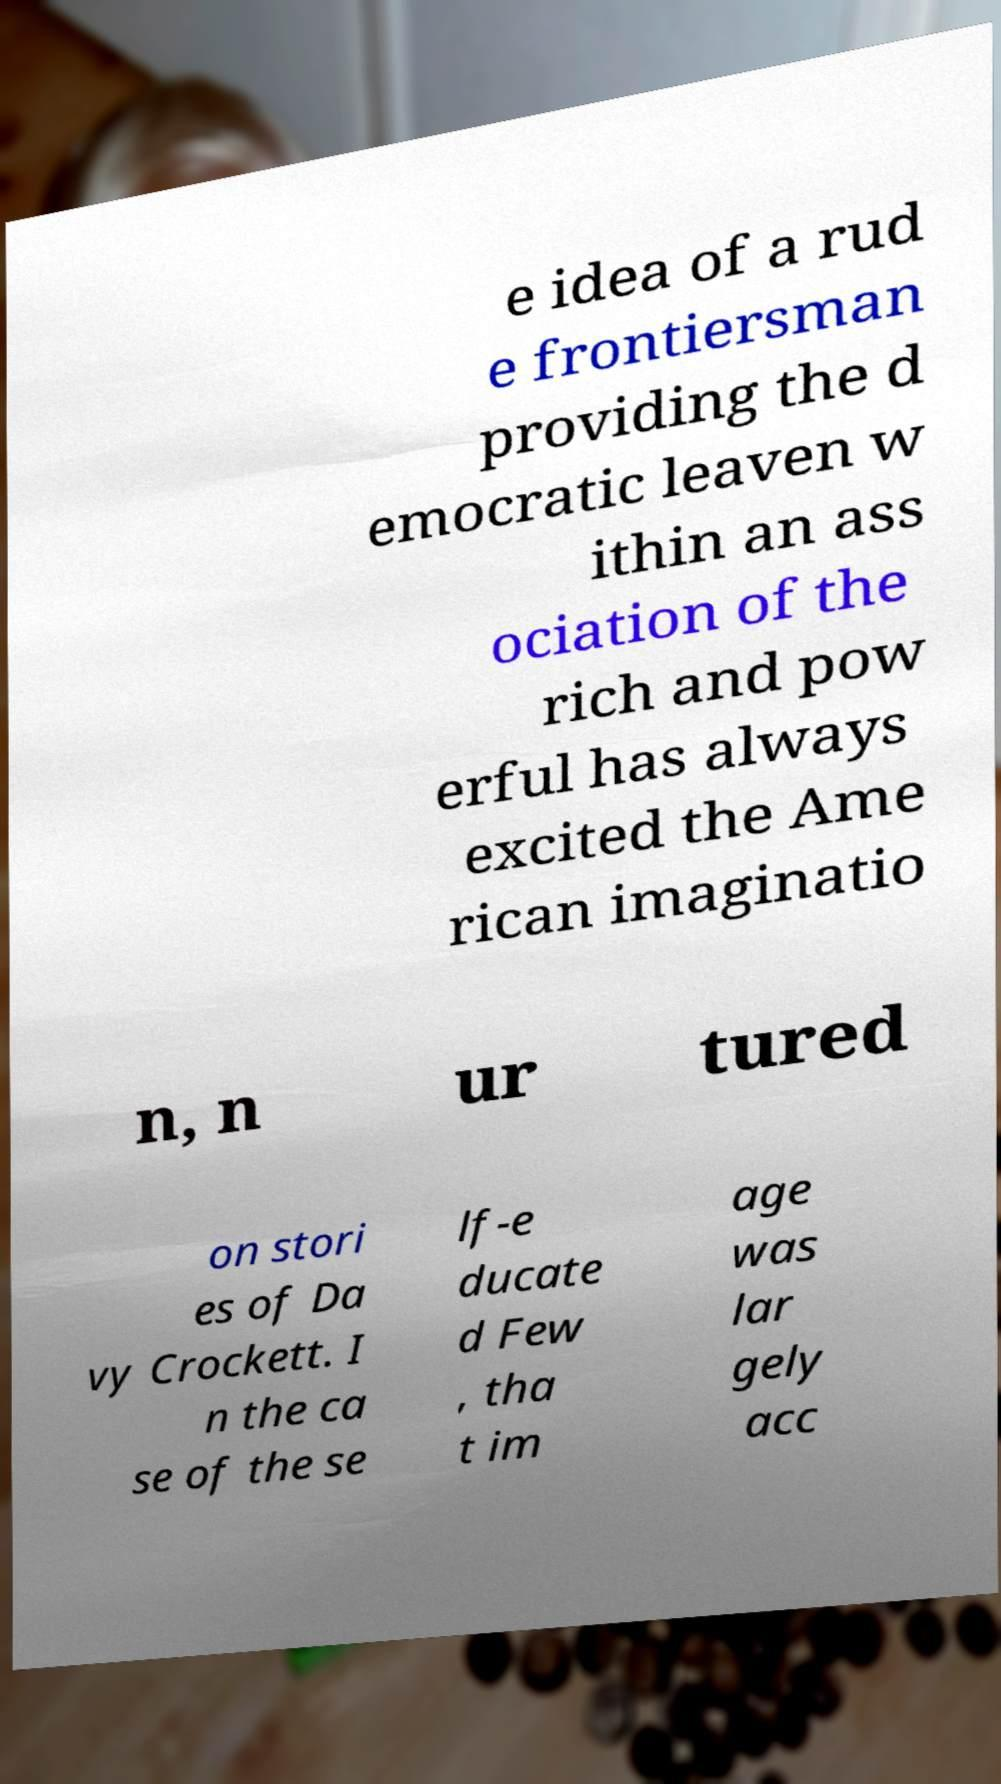There's text embedded in this image that I need extracted. Can you transcribe it verbatim? e idea of a rud e frontiersman providing the d emocratic leaven w ithin an ass ociation of the rich and pow erful has always excited the Ame rican imaginatio n, n ur tured on stori es of Da vy Crockett. I n the ca se of the se lf-e ducate d Few , tha t im age was lar gely acc 